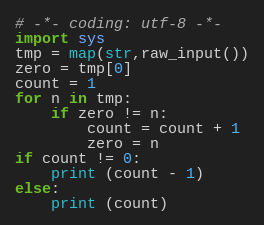Convert code to text. <code><loc_0><loc_0><loc_500><loc_500><_Python_># -*- coding: utf-8 -*-
import sys
tmp = map(str,raw_input())
zero = tmp[0]
count = 1
for n in tmp:
    if zero != n:
        count = count + 1
        zero = n
if count != 0:
    print (count - 1)
else:
    print (count)
</code> 